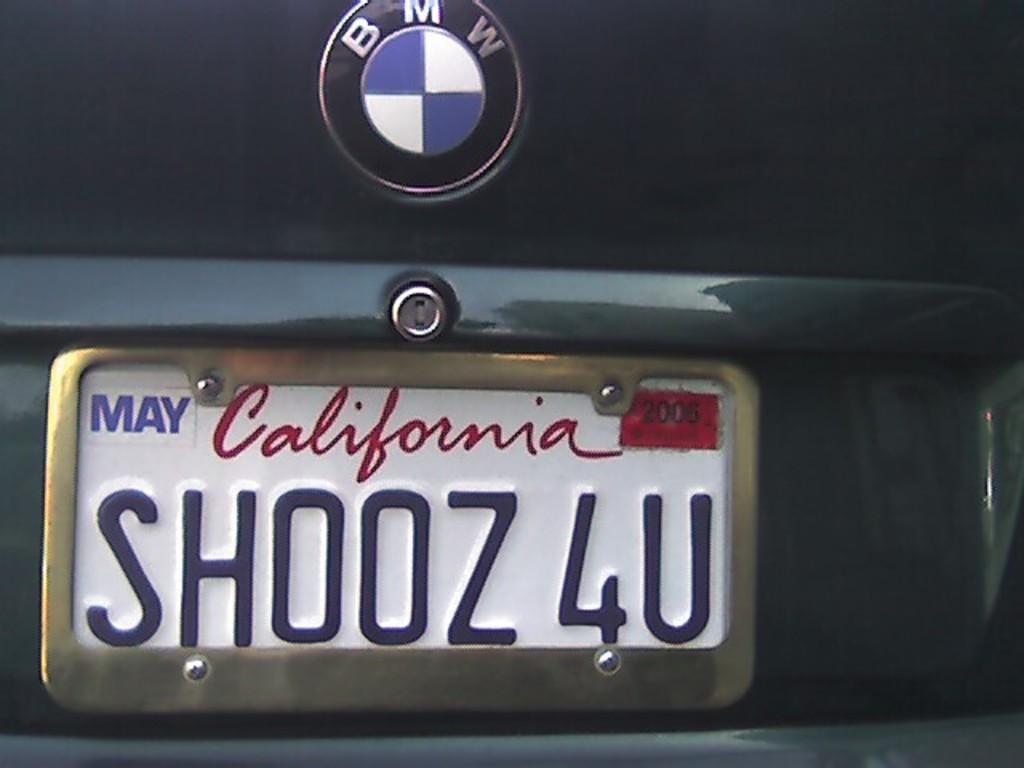<image>
Offer a succinct explanation of the picture presented. A white license plate on the back of a BMW says SH00Z4U. 